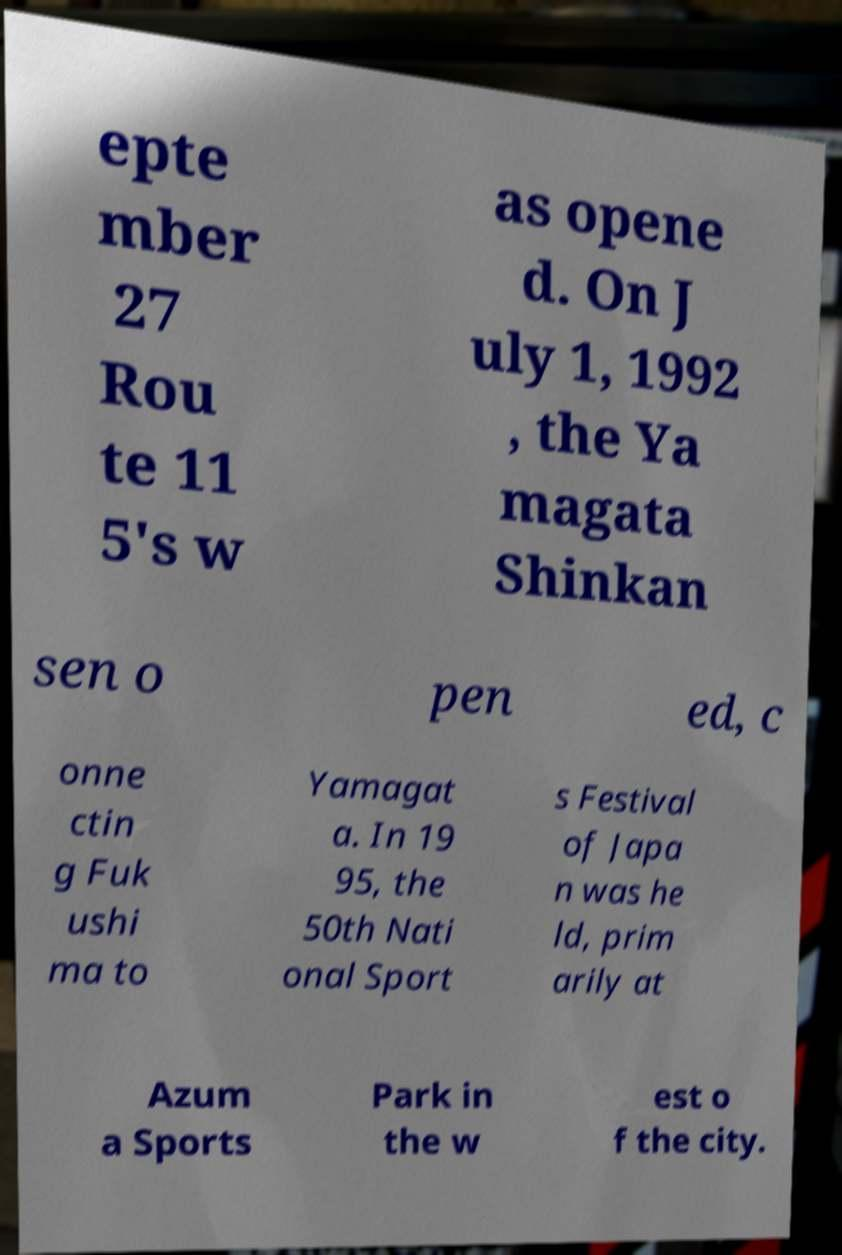Can you accurately transcribe the text from the provided image for me? epte mber 27 Rou te 11 5's w as opene d. On J uly 1, 1992 , the Ya magata Shinkan sen o pen ed, c onne ctin g Fuk ushi ma to Yamagat a. In 19 95, the 50th Nati onal Sport s Festival of Japa n was he ld, prim arily at Azum a Sports Park in the w est o f the city. 